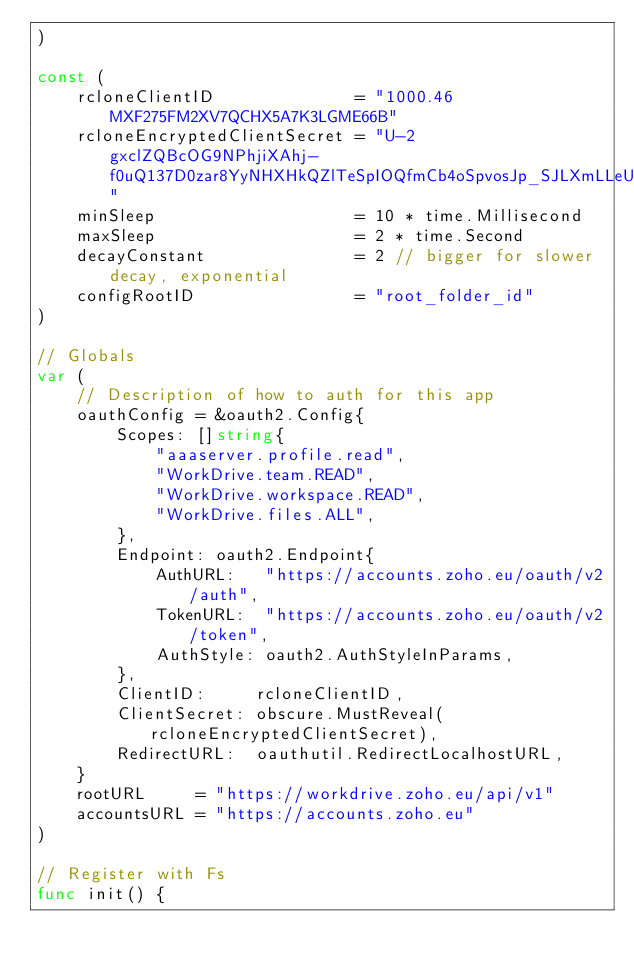<code> <loc_0><loc_0><loc_500><loc_500><_Go_>)

const (
	rcloneClientID              = "1000.46MXF275FM2XV7QCHX5A7K3LGME66B"
	rcloneEncryptedClientSecret = "U-2gxclZQBcOG9NPhjiXAhj-f0uQ137D0zar8YyNHXHkQZlTeSpIOQfmCb4oSpvosJp_SJLXmLLeUA"
	minSleep                    = 10 * time.Millisecond
	maxSleep                    = 2 * time.Second
	decayConstant               = 2 // bigger for slower decay, exponential
	configRootID                = "root_folder_id"
)

// Globals
var (
	// Description of how to auth for this app
	oauthConfig = &oauth2.Config{
		Scopes: []string{
			"aaaserver.profile.read",
			"WorkDrive.team.READ",
			"WorkDrive.workspace.READ",
			"WorkDrive.files.ALL",
		},
		Endpoint: oauth2.Endpoint{
			AuthURL:   "https://accounts.zoho.eu/oauth/v2/auth",
			TokenURL:  "https://accounts.zoho.eu/oauth/v2/token",
			AuthStyle: oauth2.AuthStyleInParams,
		},
		ClientID:     rcloneClientID,
		ClientSecret: obscure.MustReveal(rcloneEncryptedClientSecret),
		RedirectURL:  oauthutil.RedirectLocalhostURL,
	}
	rootURL     = "https://workdrive.zoho.eu/api/v1"
	accountsURL = "https://accounts.zoho.eu"
)

// Register with Fs
func init() {</code> 